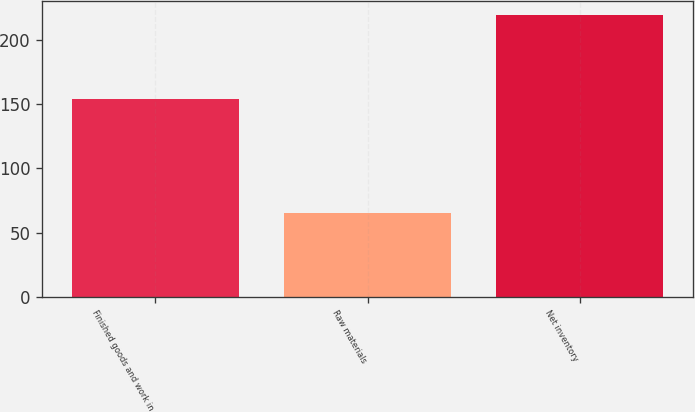Convert chart. <chart><loc_0><loc_0><loc_500><loc_500><bar_chart><fcel>Finished goods and work in<fcel>Raw materials<fcel>Net inventory<nl><fcel>154.2<fcel>65.2<fcel>219.4<nl></chart> 